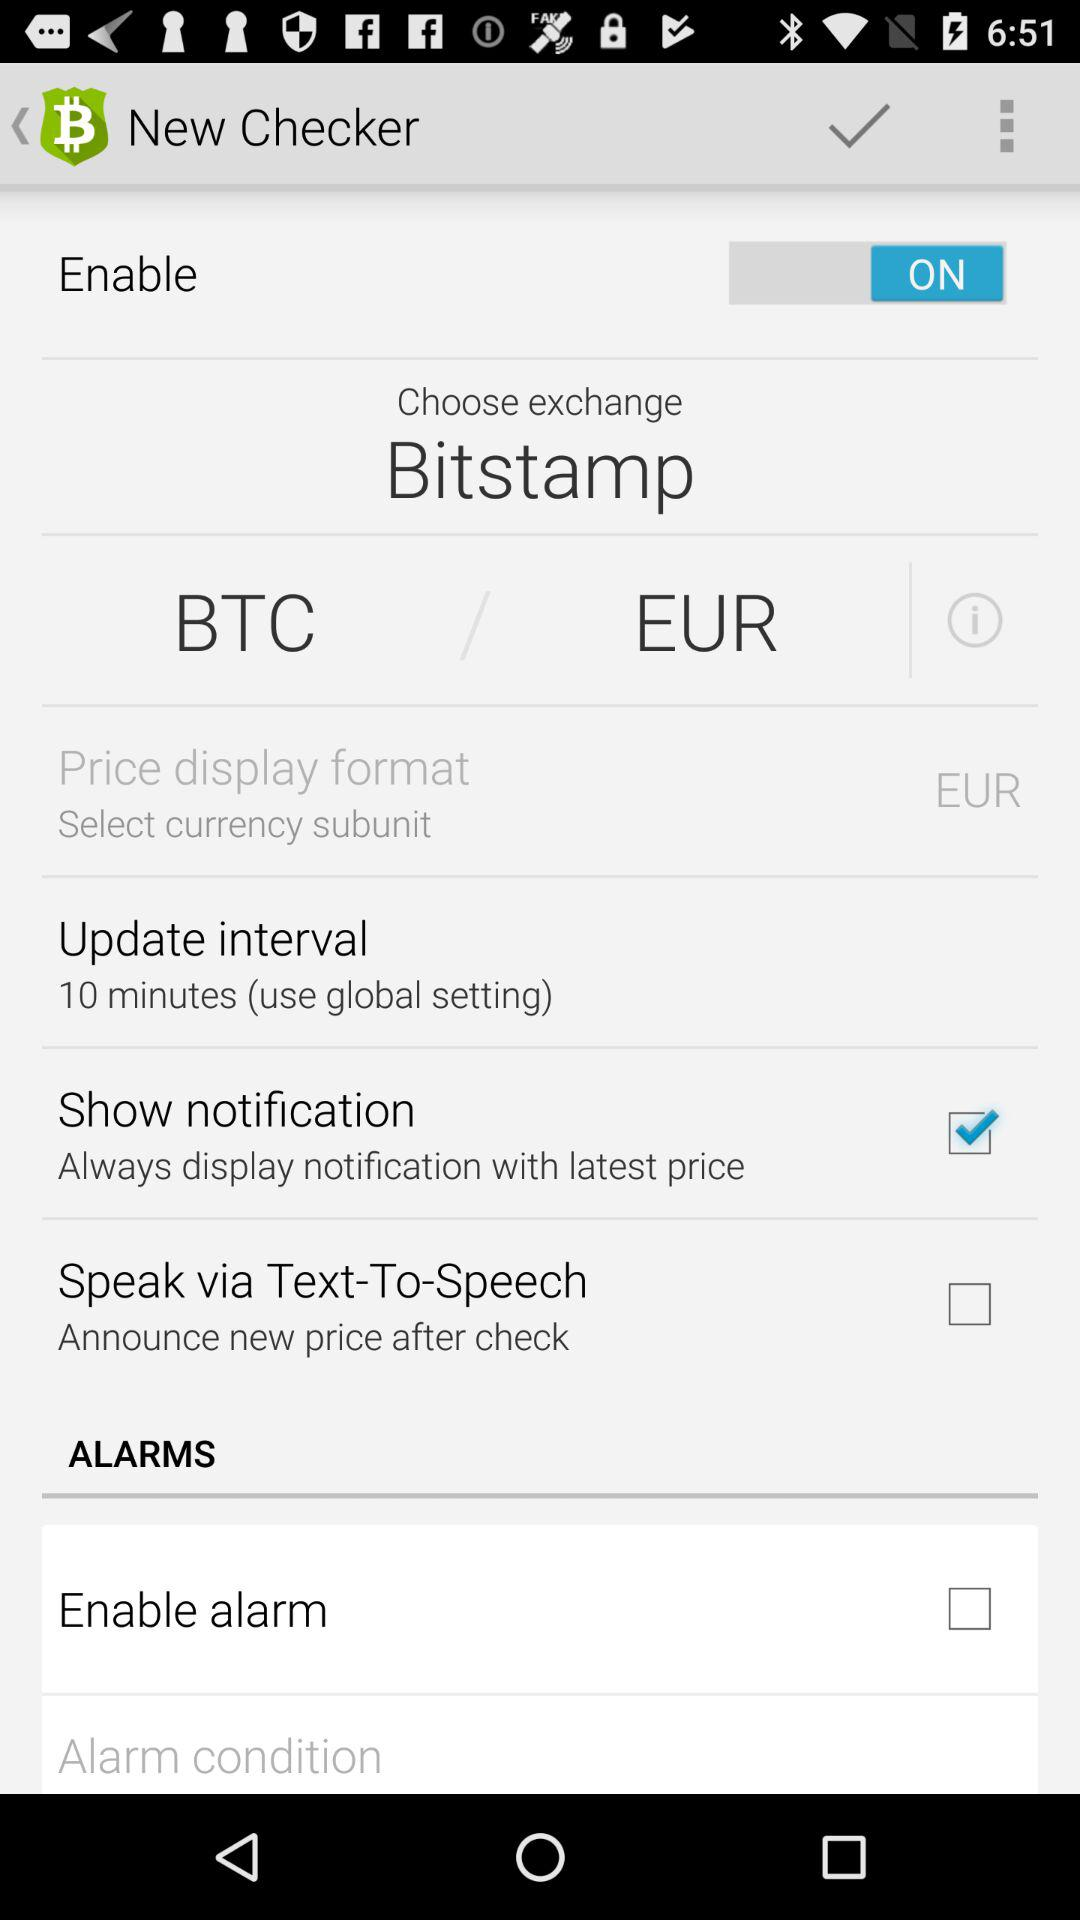What are the options available in "ALARMS"? The option available in "ALARMS" is "Enable alarm". 